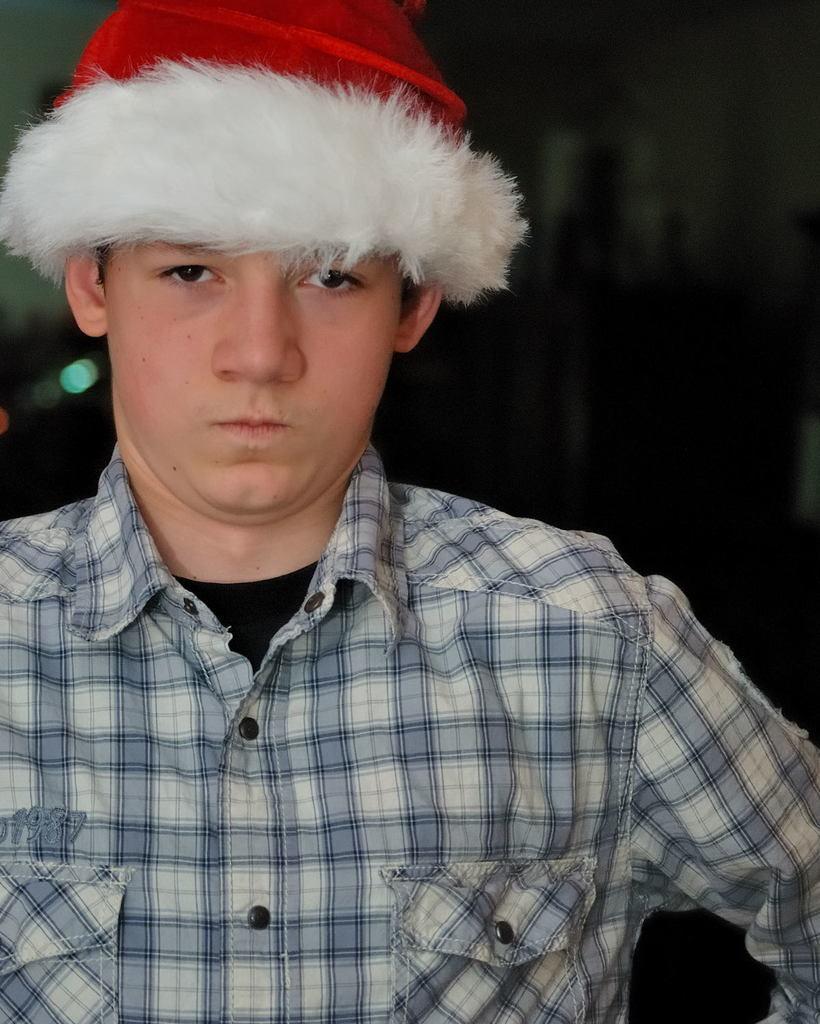In one or two sentences, can you explain what this image depicts? In the image we can see a boy wearing clothes and Santa cap and the background is dark. 